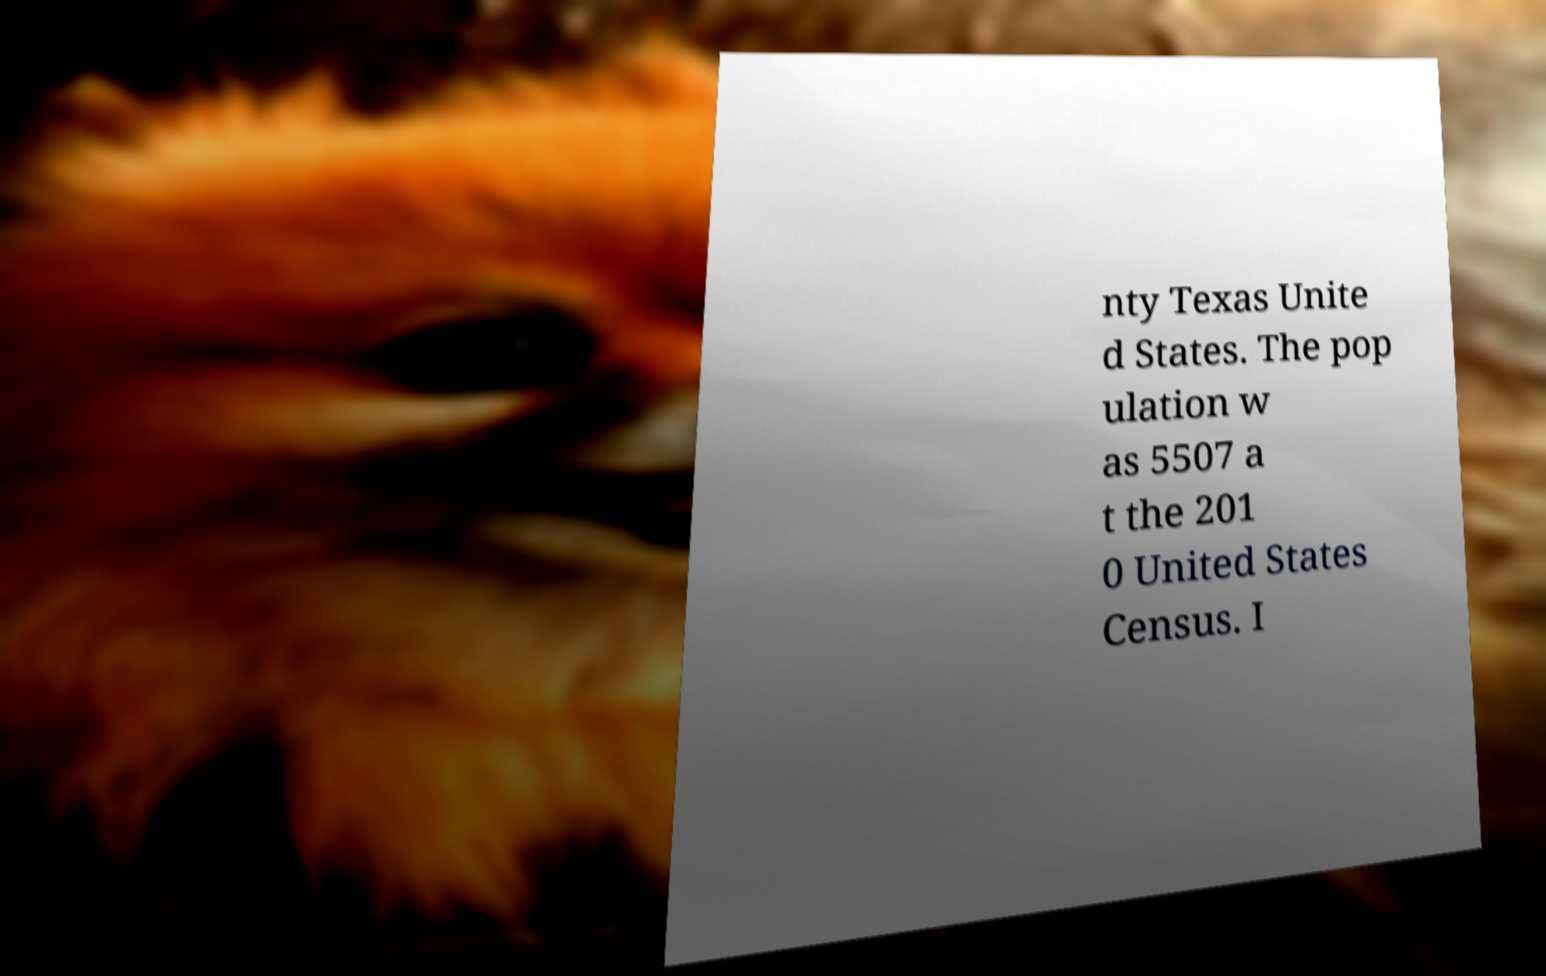What messages or text are displayed in this image? I need them in a readable, typed format. nty Texas Unite d States. The pop ulation w as 5507 a t the 201 0 United States Census. I 